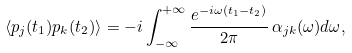Convert formula to latex. <formula><loc_0><loc_0><loc_500><loc_500>\langle p _ { j } ( t _ { 1 } ) p _ { k } ( t _ { 2 } ) \rangle = - i \int _ { - \infty } ^ { + \infty } \frac { e ^ { - i \omega ( t _ { 1 } - t _ { 2 } ) } } { 2 \pi } \, \alpha _ { j k } ( \omega ) d \omega ,</formula> 